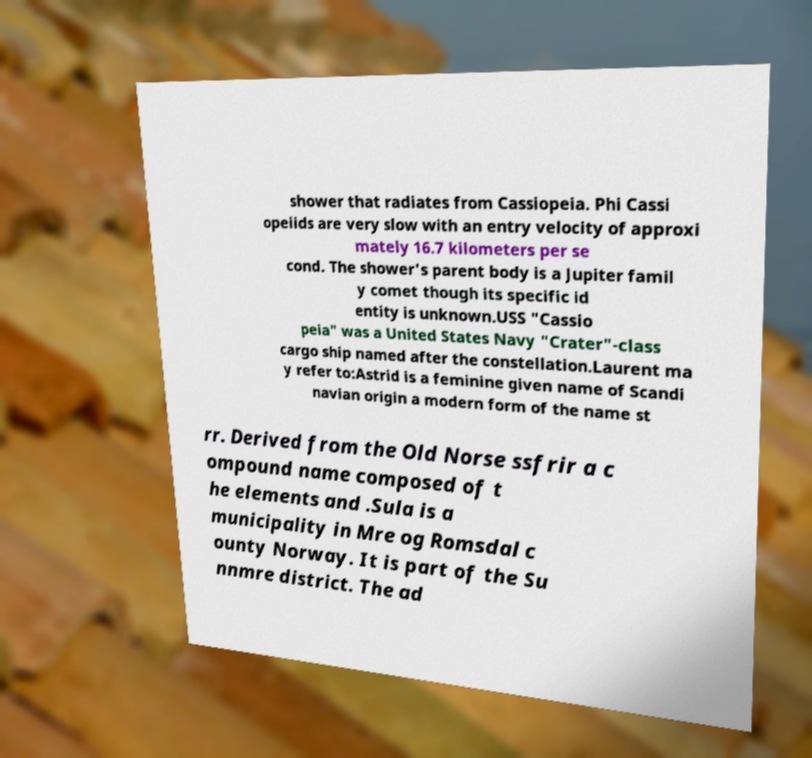I need the written content from this picture converted into text. Can you do that? shower that radiates from Cassiopeia. Phi Cassi opeiids are very slow with an entry velocity of approxi mately 16.7 kilometers per se cond. The shower's parent body is a Jupiter famil y comet though its specific id entity is unknown.USS "Cassio peia" was a United States Navy "Crater"-class cargo ship named after the constellation.Laurent ma y refer to:Astrid is a feminine given name of Scandi navian origin a modern form of the name st rr. Derived from the Old Norse ssfrir a c ompound name composed of t he elements and .Sula is a municipality in Mre og Romsdal c ounty Norway. It is part of the Su nnmre district. The ad 